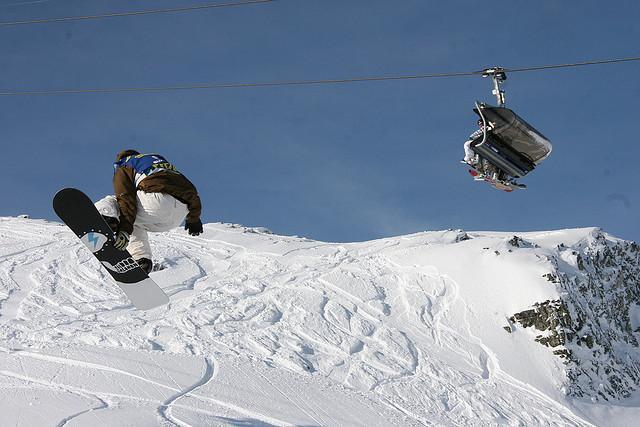How many people are in the chair lift?
Give a very brief answer. 3. How many snowboards can be seen?
Give a very brief answer. 1. How many giraffes are in this picture?
Give a very brief answer. 0. 